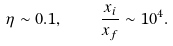<formula> <loc_0><loc_0><loc_500><loc_500>\eta \sim 0 . 1 , \quad \frac { x _ { i } } { x _ { f } } \sim 1 0 ^ { 4 } .</formula> 